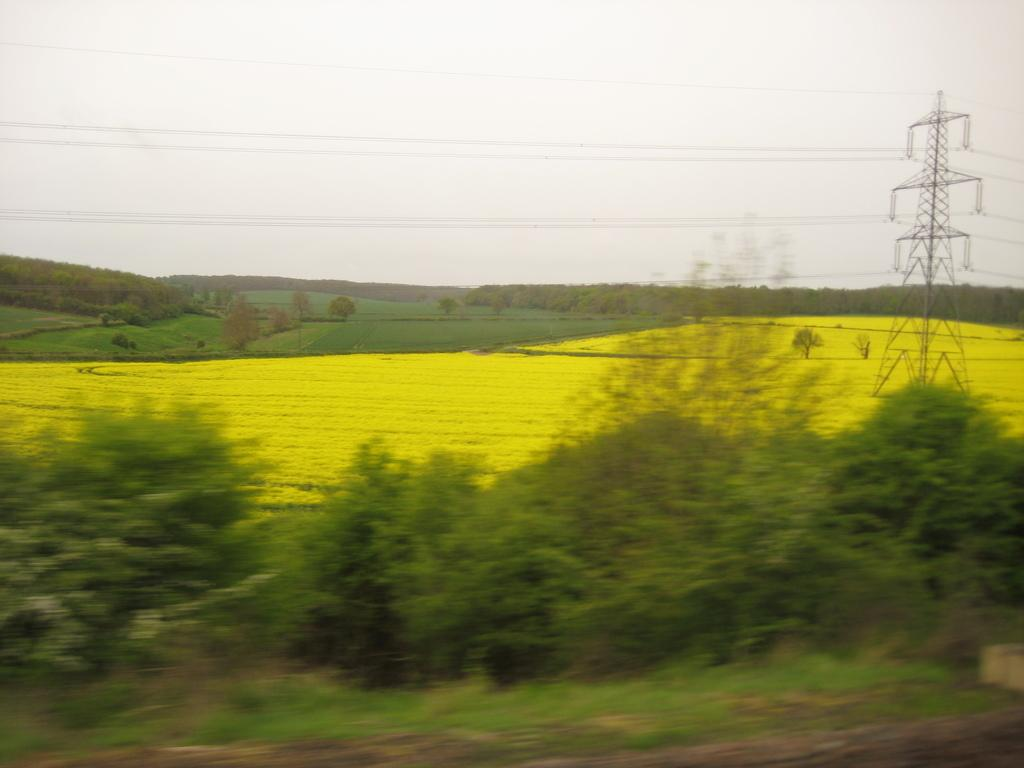What type of vegetation is at the bottom of the image? There are trees at the bottom of the image. What is located in the middle of the image? There are crops in the middle of the image. What can be seen on the right side of the image? There is an electric pole on the right side of the image. What is visible at the top of the image? The sky is visible at the top of the image. What verse is recited by the trees in the image? There are no verses being recited by the trees in the image, as trees do not have the ability to recite verses. How does the wealth of the crops in the image affect the electric pole? There is no indication of wealth in the image, and the electric pole is not affected by the crops. 